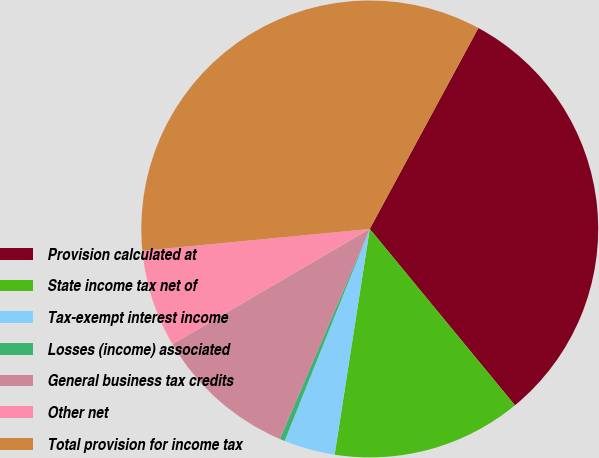<chart> <loc_0><loc_0><loc_500><loc_500><pie_chart><fcel>Provision calculated at<fcel>State income tax net of<fcel>Tax-exempt interest income<fcel>Losses (income) associated<fcel>General business tax credits<fcel>Other net<fcel>Total provision for income tax<nl><fcel>31.15%<fcel>13.42%<fcel>3.62%<fcel>0.36%<fcel>10.15%<fcel>6.89%<fcel>34.41%<nl></chart> 